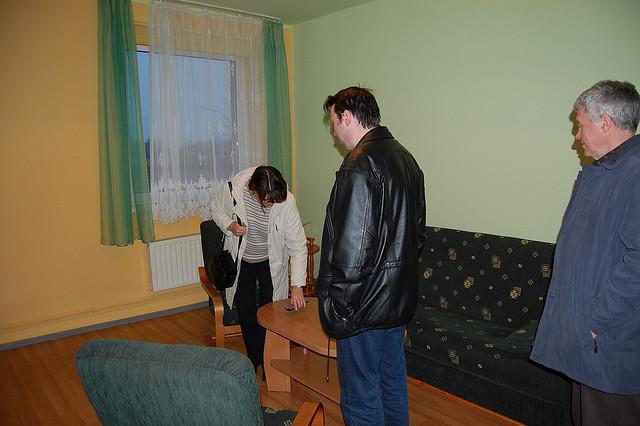Who is the old man in the photo?
Answer briefly. Father. Are the people having fun?
Keep it brief. No. Is there a couch in this room?
Short answer required. Yes. What color is the wall to the right of the man in the leather coat?
Quick response, please. Green. Are they going out?
Answer briefly. Yes. 